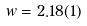Convert formula to latex. <formula><loc_0><loc_0><loc_500><loc_500>w = 2 . 1 8 ( 1 )</formula> 